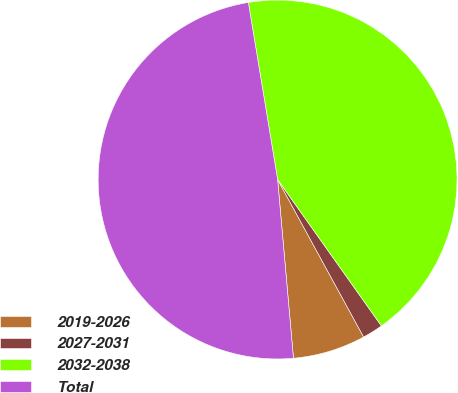Convert chart to OTSL. <chart><loc_0><loc_0><loc_500><loc_500><pie_chart><fcel>2019-2026<fcel>2027-2031<fcel>2032-2038<fcel>Total<nl><fcel>6.55%<fcel>1.86%<fcel>42.79%<fcel>48.8%<nl></chart> 